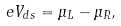Convert formula to latex. <formula><loc_0><loc_0><loc_500><loc_500>e V _ { d s } = \mu _ { L } - \mu _ { R } ,</formula> 